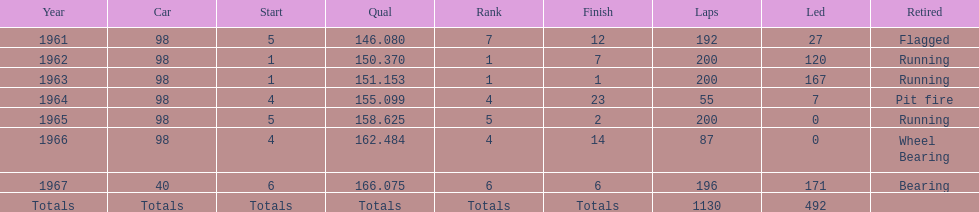Number of times to finish the races running. 3. 